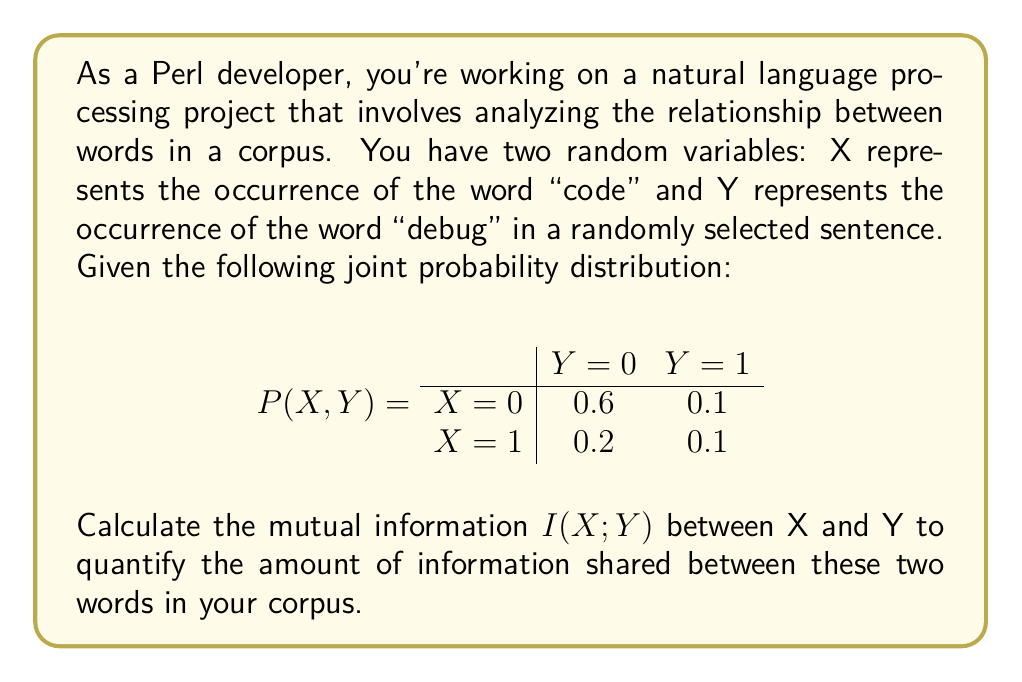Help me with this question. To calculate the mutual information $I(X;Y)$, we'll follow these steps:

1. Calculate the marginal probabilities $P(X)$ and $P(Y)$:
   $P(X=0) = 0.6 + 0.1 = 0.7$
   $P(X=1) = 0.2 + 0.1 = 0.3$
   $P(Y=0) = 0.6 + 0.2 = 0.8$
   $P(Y=1) = 0.1 + 0.1 = 0.2$

2. Use the formula for mutual information:
   $$I(X;Y) = \sum_{x \in X} \sum_{y \in Y} P(x,y) \log_2 \frac{P(x,y)}{P(x)P(y)}$$

3. Calculate each term in the sum:
   For $X=0, Y=0$: $0.6 \log_2 \frac{0.6}{0.7 \cdot 0.8} = 0.6 \log_2 1.0714 = 0.0416$
   For $X=0, Y=1$: $0.1 \log_2 \frac{0.1}{0.7 \cdot 0.2} = 0.1 \log_2 0.7143 = -0.0457$
   For $X=1, Y=0$: $0.2 \log_2 \frac{0.2}{0.3 \cdot 0.8} = 0.2 \log_2 0.8333 = -0.0272$
   For $X=1, Y=1$: $0.1 \log_2 \frac{0.1}{0.3 \cdot 0.2} = 0.1 \log_2 1.6667 = 0.0736$

4. Sum all the terms:
   $I(X;Y) = 0.0416 + (-0.0457) + (-0.0272) + 0.0736 = 0.0423$ bits

The mutual information $I(X;Y)$ quantifies the amount of information shared between the occurrences of "code" and "debug" in your corpus.
Answer: $I(X;Y) \approx 0.0423$ bits 